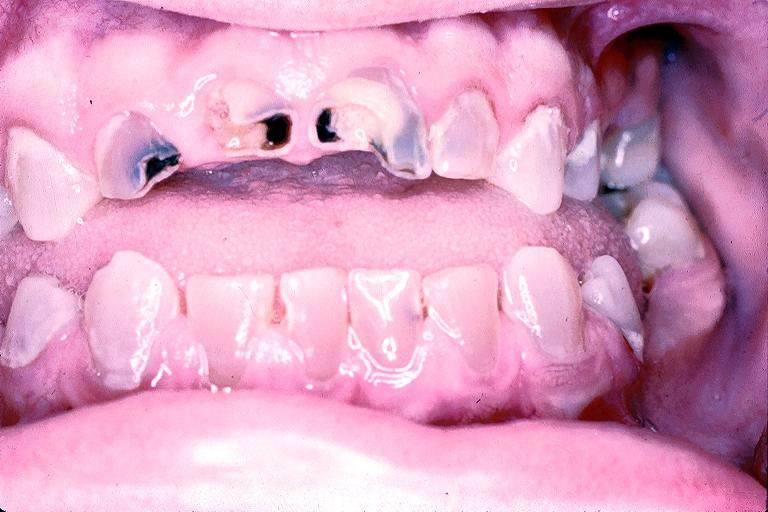s oral present?
Answer the question using a single word or phrase. Yes 